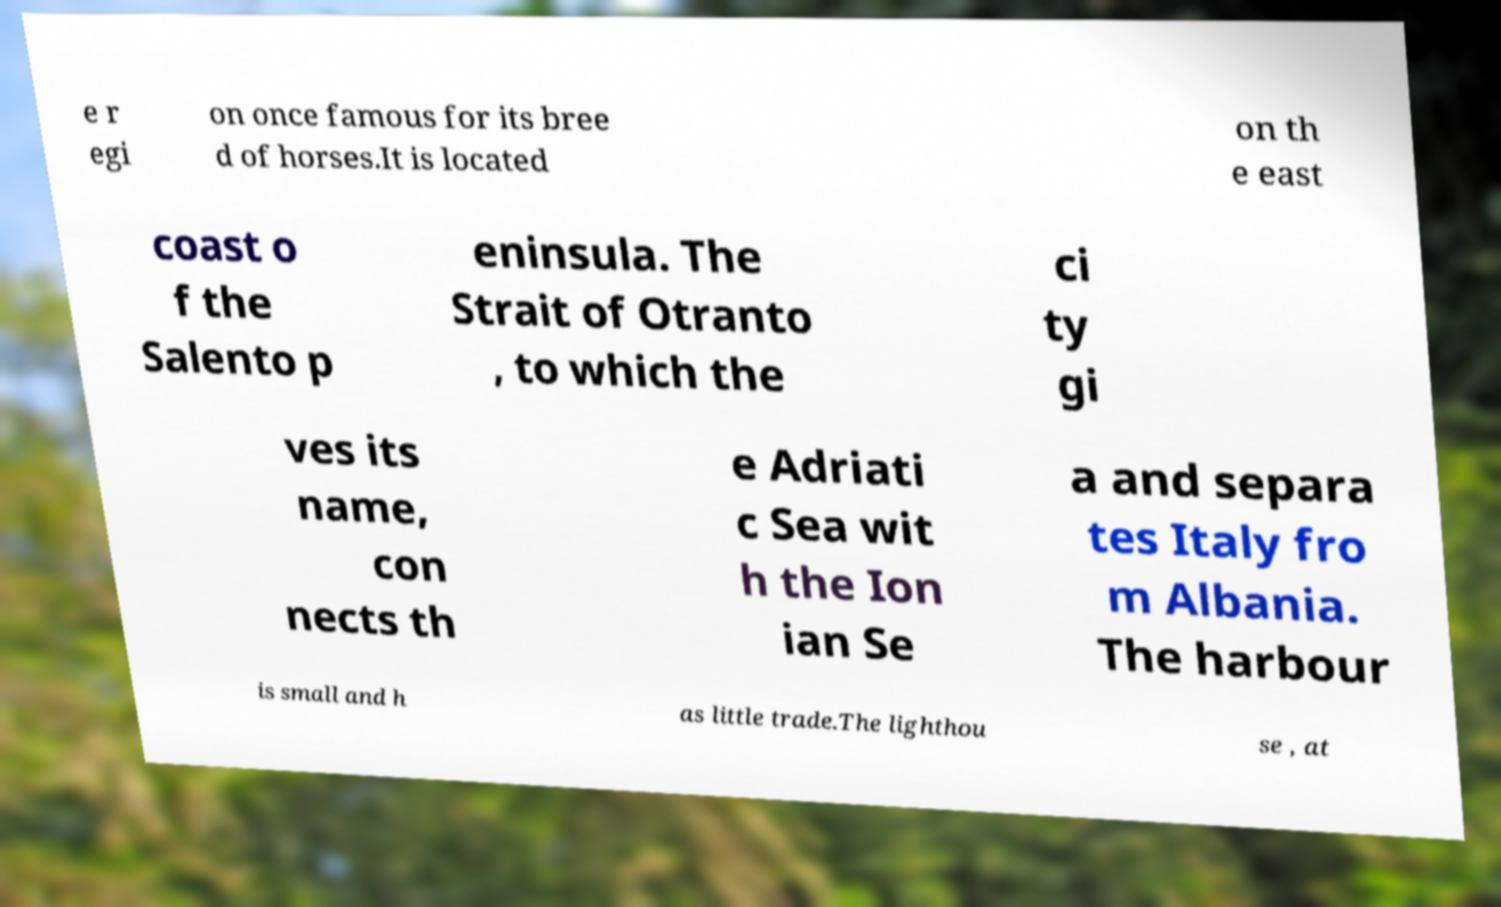There's text embedded in this image that I need extracted. Can you transcribe it verbatim? e r egi on once famous for its bree d of horses.It is located on th e east coast o f the Salento p eninsula. The Strait of Otranto , to which the ci ty gi ves its name, con nects th e Adriati c Sea wit h the Ion ian Se a and separa tes Italy fro m Albania. The harbour is small and h as little trade.The lighthou se , at 